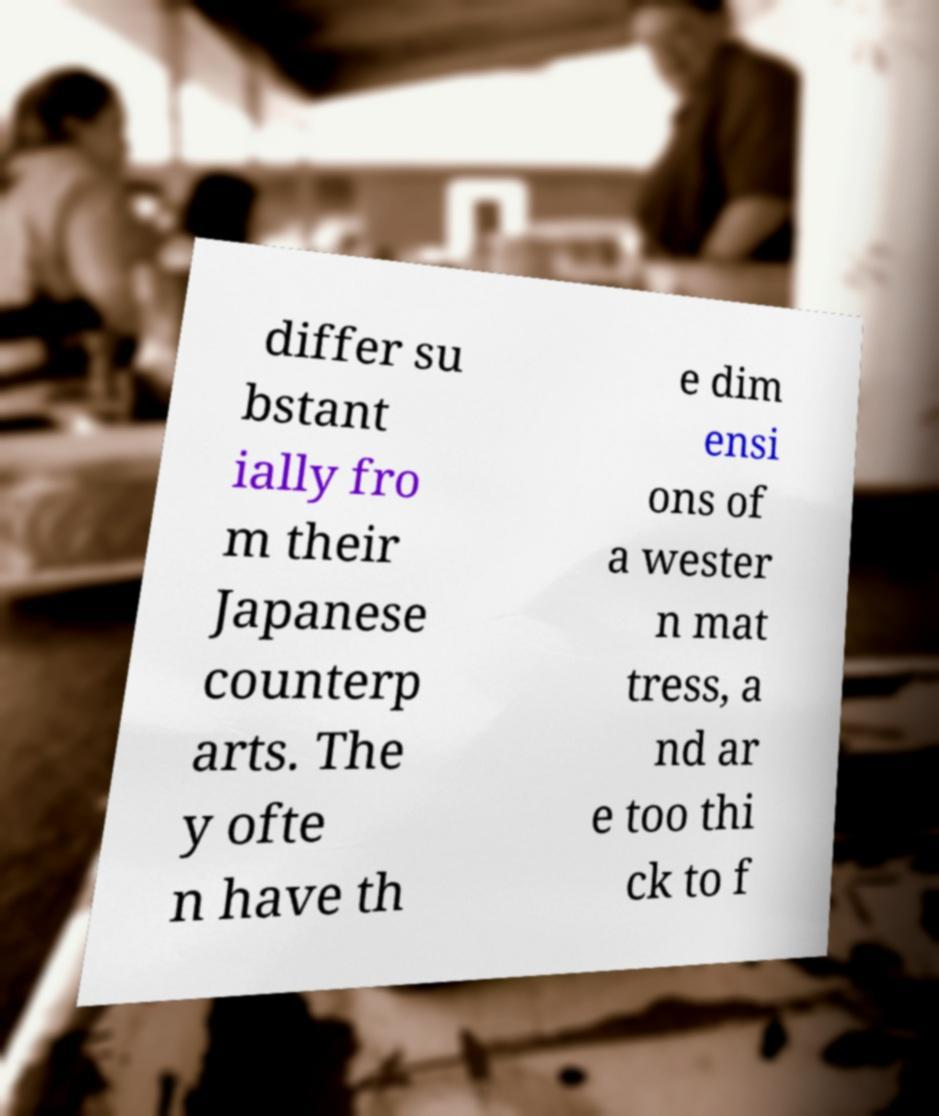What messages or text are displayed in this image? I need them in a readable, typed format. differ su bstant ially fro m their Japanese counterp arts. The y ofte n have th e dim ensi ons of a wester n mat tress, a nd ar e too thi ck to f 